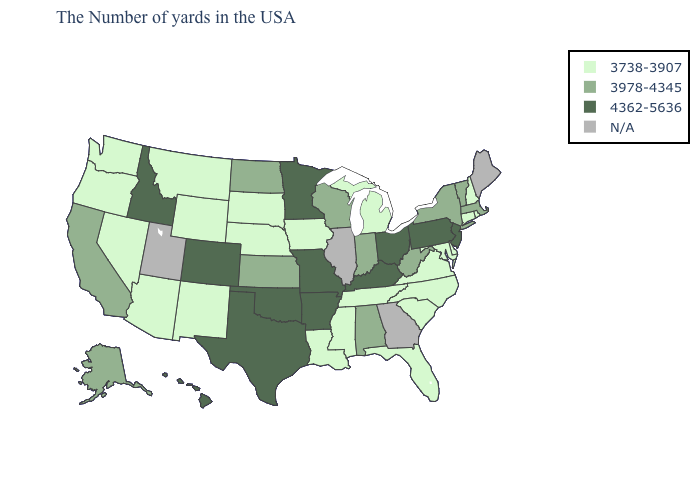How many symbols are there in the legend?
Short answer required. 4. What is the value of Virginia?
Give a very brief answer. 3738-3907. What is the value of Indiana?
Concise answer only. 3978-4345. Name the states that have a value in the range 3738-3907?
Keep it brief. Rhode Island, New Hampshire, Connecticut, Delaware, Maryland, Virginia, North Carolina, South Carolina, Florida, Michigan, Tennessee, Mississippi, Louisiana, Iowa, Nebraska, South Dakota, Wyoming, New Mexico, Montana, Arizona, Nevada, Washington, Oregon. Name the states that have a value in the range 3738-3907?
Short answer required. Rhode Island, New Hampshire, Connecticut, Delaware, Maryland, Virginia, North Carolina, South Carolina, Florida, Michigan, Tennessee, Mississippi, Louisiana, Iowa, Nebraska, South Dakota, Wyoming, New Mexico, Montana, Arizona, Nevada, Washington, Oregon. What is the lowest value in the MidWest?
Keep it brief. 3738-3907. How many symbols are there in the legend?
Answer briefly. 4. What is the lowest value in the USA?
Be succinct. 3738-3907. What is the value of Missouri?
Give a very brief answer. 4362-5636. What is the value of Wyoming?
Concise answer only. 3738-3907. Which states have the lowest value in the West?
Be succinct. Wyoming, New Mexico, Montana, Arizona, Nevada, Washington, Oregon. Name the states that have a value in the range 3738-3907?
Quick response, please. Rhode Island, New Hampshire, Connecticut, Delaware, Maryland, Virginia, North Carolina, South Carolina, Florida, Michigan, Tennessee, Mississippi, Louisiana, Iowa, Nebraska, South Dakota, Wyoming, New Mexico, Montana, Arizona, Nevada, Washington, Oregon. Among the states that border South Carolina , which have the highest value?
Give a very brief answer. North Carolina. What is the lowest value in states that border Vermont?
Answer briefly. 3738-3907. 